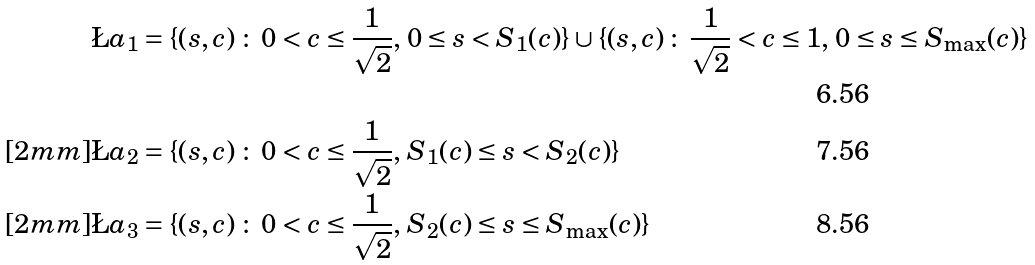Convert formula to latex. <formula><loc_0><loc_0><loc_500><loc_500>\L a _ { 1 } & = \{ ( s , c ) \, \colon \, 0 < c \leq \frac { 1 } { \sqrt { 2 } } , \, 0 \leq s < S _ { 1 } ( c ) \} \cup \{ ( s , c ) \, \colon \, \frac { 1 } { \sqrt { 2 } } < c \leq 1 , \, 0 \leq s \leq S _ { \max } ( c ) \} \\ [ 2 m m ] \L a _ { 2 } & = \{ ( s , c ) \, \colon \, 0 < c \leq \frac { 1 } { \sqrt { 2 } } , \, S _ { 1 } ( c ) \leq s < S _ { 2 } ( c ) \} \\ [ 2 m m ] \L a _ { 3 } & = \{ ( s , c ) \, \colon \, 0 < c \leq \frac { 1 } { \sqrt { 2 } } , \, S _ { 2 } ( c ) \leq s \leq S _ { \max } ( c ) \}</formula> 